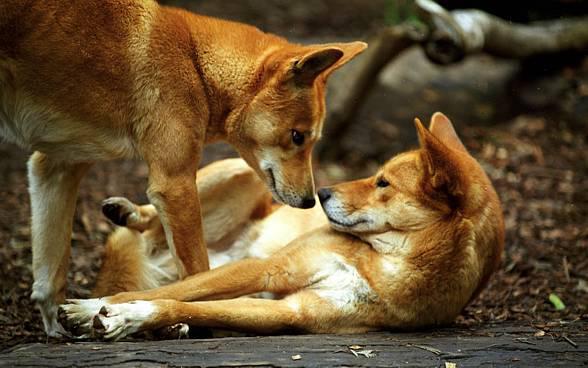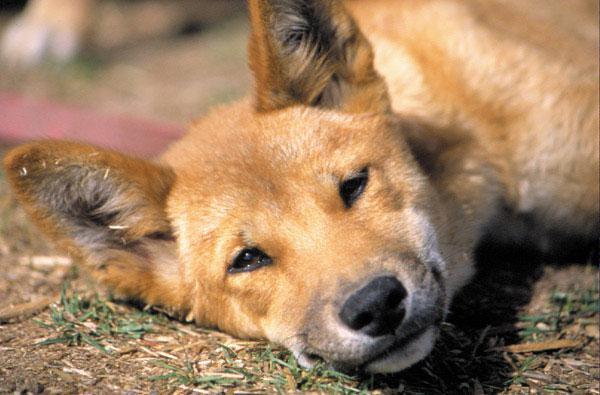The first image is the image on the left, the second image is the image on the right. Assess this claim about the two images: "There are at most two dingoes.". Correct or not? Answer yes or no. No. The first image is the image on the left, the second image is the image on the right. Given the left and right images, does the statement "The wild dog in the image on the right is lying down outside." hold true? Answer yes or no. Yes. 